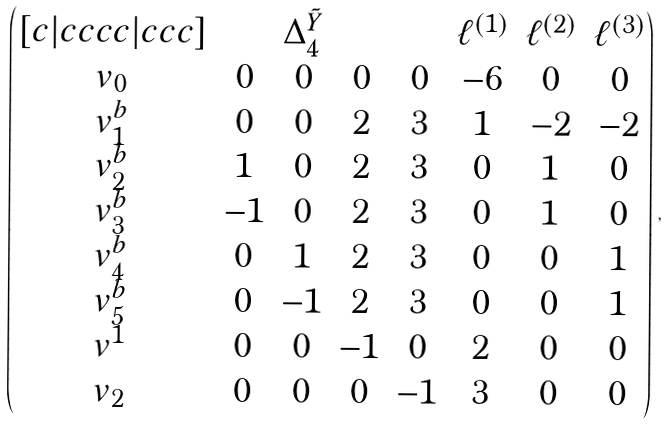Convert formula to latex. <formula><loc_0><loc_0><loc_500><loc_500>\begin{pmatrix} [ c | c c c c | c c c ] & & \Delta _ { 4 } ^ { \tilde { Y } } & & & \ell ^ { ( 1 ) } & \ell ^ { ( 2 ) } & \ell ^ { ( 3 ) } \\ v _ { 0 } & 0 & 0 & 0 & 0 & - 6 & 0 & 0 \\ v ^ { b } _ { 1 } & 0 & 0 & 2 & 3 & 1 & - 2 & - 2 \\ v ^ { b } _ { 2 } & 1 & 0 & 2 & 3 & 0 & 1 & 0 \\ v ^ { b } _ { 3 } & - 1 & 0 & 2 & 3 & 0 & 1 & 0 \\ v ^ { b } _ { 4 } & 0 & 1 & 2 & 3 & 0 & 0 & 1 \\ v ^ { b } _ { 5 } & 0 & - 1 & 2 & 3 & 0 & 0 & 1 \\ v ^ { 1 } & 0 & 0 & - 1 & 0 & 2 & 0 & 0 \\ v _ { 2 } & 0 & 0 & 0 & - 1 & 3 & 0 & 0 \end{pmatrix} \, ,</formula> 